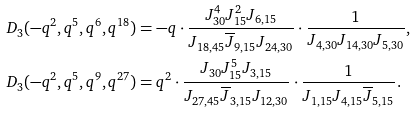<formula> <loc_0><loc_0><loc_500><loc_500>D _ { 3 } ( - q ^ { 2 } , q ^ { 5 } , q ^ { 6 } , q ^ { 1 8 } ) & = - q \cdot \frac { J _ { 3 0 } ^ { 4 } J _ { 1 5 } ^ { 2 } J _ { 6 , 1 5 } } { J _ { 1 8 , 4 5 } \overline { J } _ { 9 , 1 5 } J _ { 2 4 , 3 0 } } \cdot \frac { 1 } { J _ { 4 , 3 0 } J _ { 1 4 , 3 0 } J _ { 5 , 3 0 } } , \\ D _ { 3 } ( - q ^ { 2 } , q ^ { 5 } , q ^ { 9 } , q ^ { 2 7 } ) & = q ^ { 2 } \cdot \frac { J _ { 3 0 } J _ { 1 5 } ^ { 5 } J _ { 3 , 1 5 } } { J _ { 2 7 , 4 5 } \overline { J } _ { 3 , 1 5 } J _ { 1 2 , 3 0 } } \cdot \frac { 1 } { J _ { 1 , 1 5 } J _ { 4 , 1 5 } \overline { J } _ { 5 , 1 5 } } .</formula> 